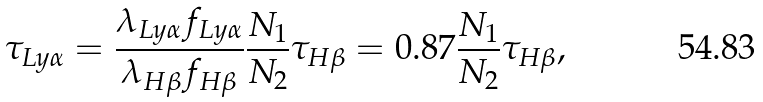Convert formula to latex. <formula><loc_0><loc_0><loc_500><loc_500>\tau _ { L y \alpha } = \frac { \lambda _ { L y \alpha } f _ { L y \alpha } } { \lambda _ { H \beta } f _ { H \beta } } \frac { N _ { 1 } } { N _ { 2 } } \tau _ { H \beta } = 0 . 8 7 \frac { N _ { 1 } } { N _ { 2 } } \tau _ { H \beta } ,</formula> 